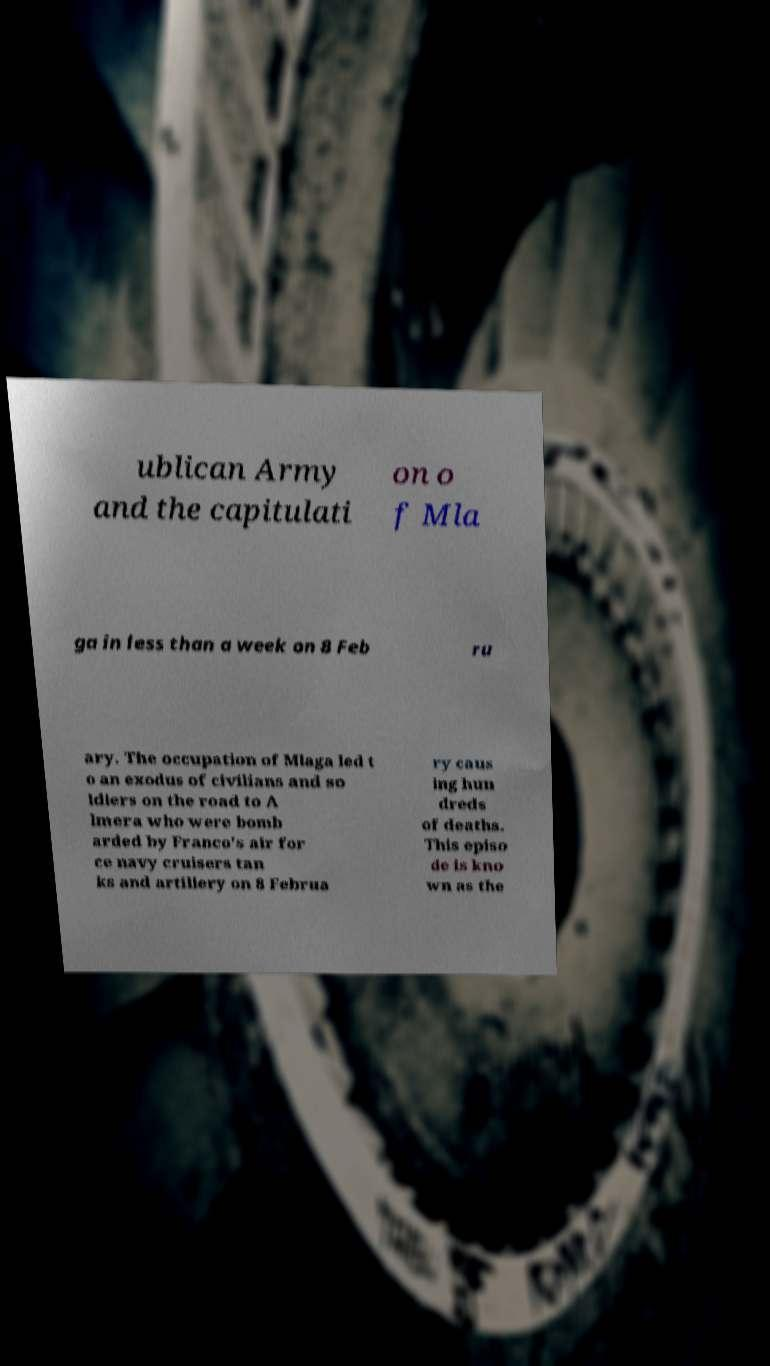What messages or text are displayed in this image? I need them in a readable, typed format. ublican Army and the capitulati on o f Mla ga in less than a week on 8 Feb ru ary. The occupation of Mlaga led t o an exodus of civilians and so ldiers on the road to A lmera who were bomb arded by Franco's air for ce navy cruisers tan ks and artillery on 8 Februa ry caus ing hun dreds of deaths. This episo de is kno wn as the 